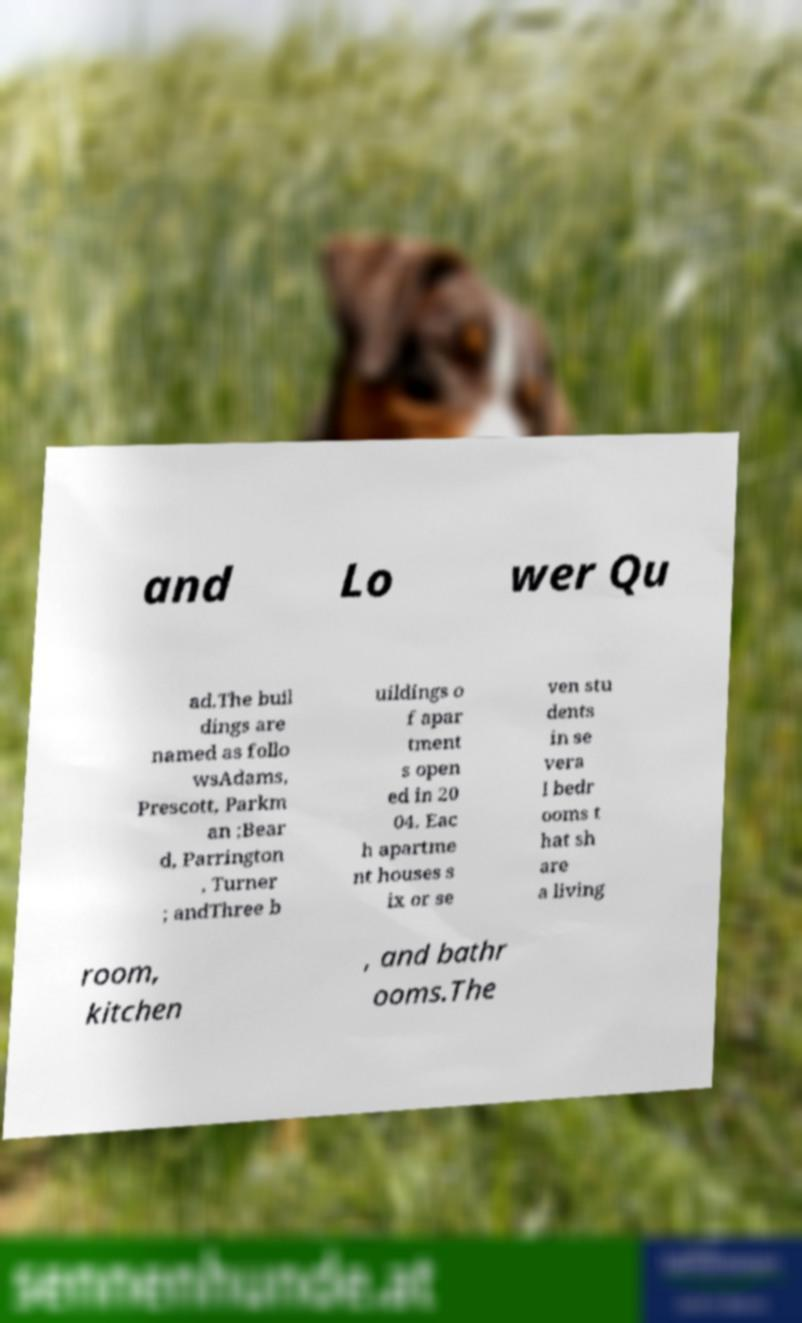What messages or text are displayed in this image? I need them in a readable, typed format. and Lo wer Qu ad.The buil dings are named as follo wsAdams, Prescott, Parkm an ;Bear d, Parrington , Turner ; andThree b uildings o f apar tment s open ed in 20 04. Eac h apartme nt houses s ix or se ven stu dents in se vera l bedr ooms t hat sh are a living room, kitchen , and bathr ooms.The 